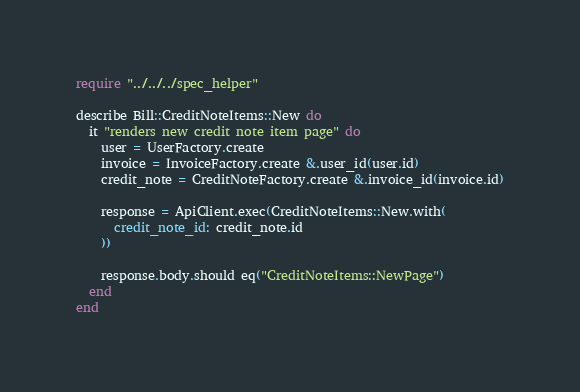Convert code to text. <code><loc_0><loc_0><loc_500><loc_500><_Crystal_>require "../../../spec_helper"

describe Bill::CreditNoteItems::New do
  it "renders new credit note item page" do
    user = UserFactory.create
    invoice = InvoiceFactory.create &.user_id(user.id)
    credit_note = CreditNoteFactory.create &.invoice_id(invoice.id)

    response = ApiClient.exec(CreditNoteItems::New.with(
      credit_note_id: credit_note.id
    ))

    response.body.should eq("CreditNoteItems::NewPage")
  end
end
</code> 